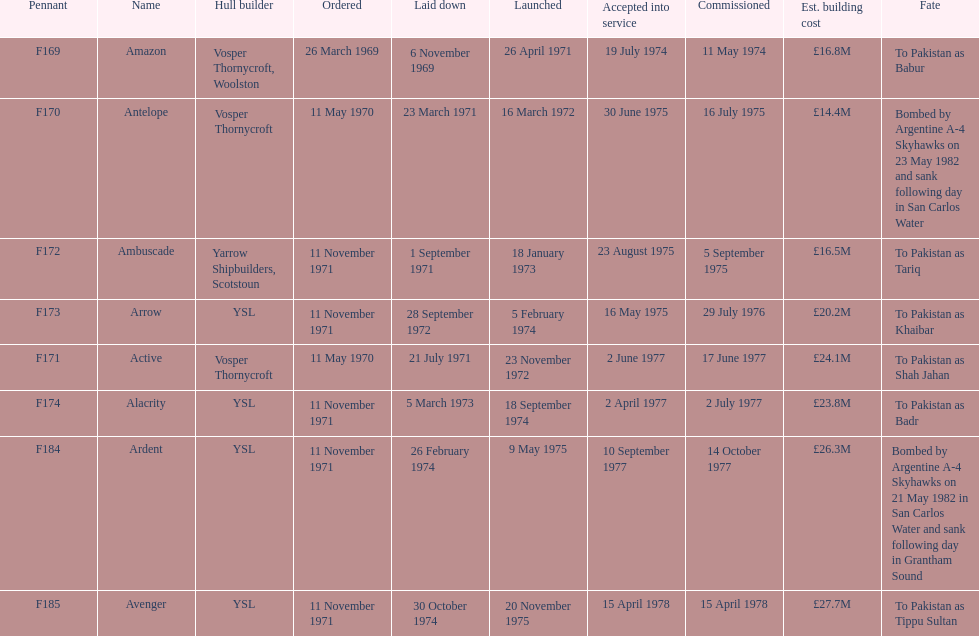What is the final surname displayed on this diagram? Avenger. 